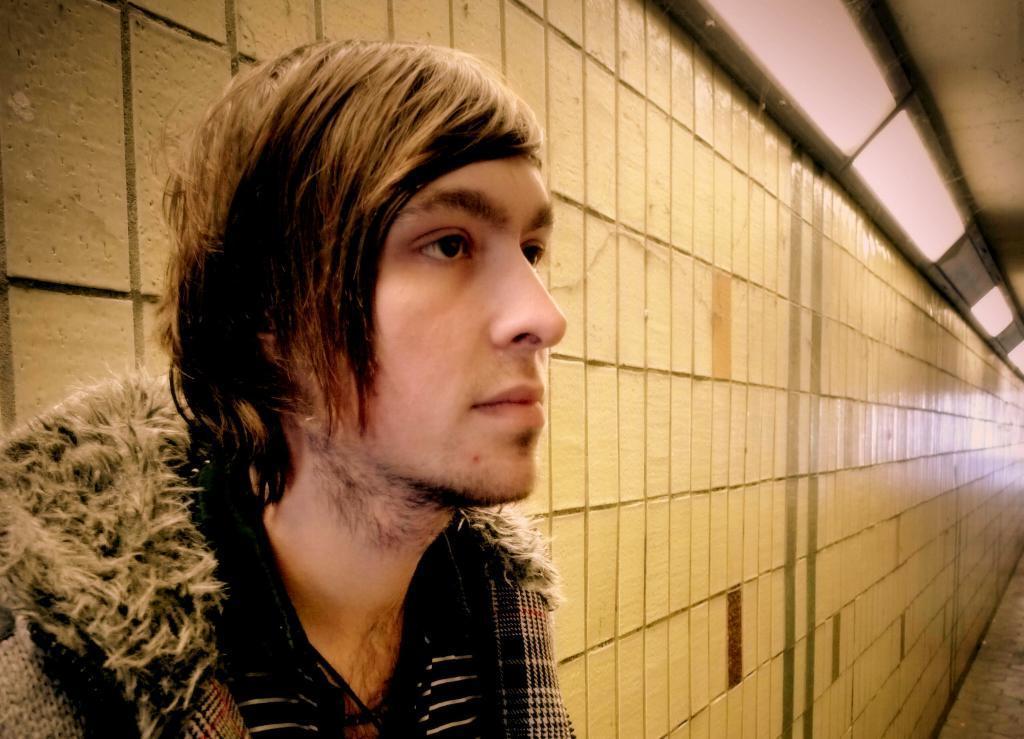Can you describe this image briefly? In this image, I can see the man. This is the wall. I think these are the lights, which are attached to the wall. 